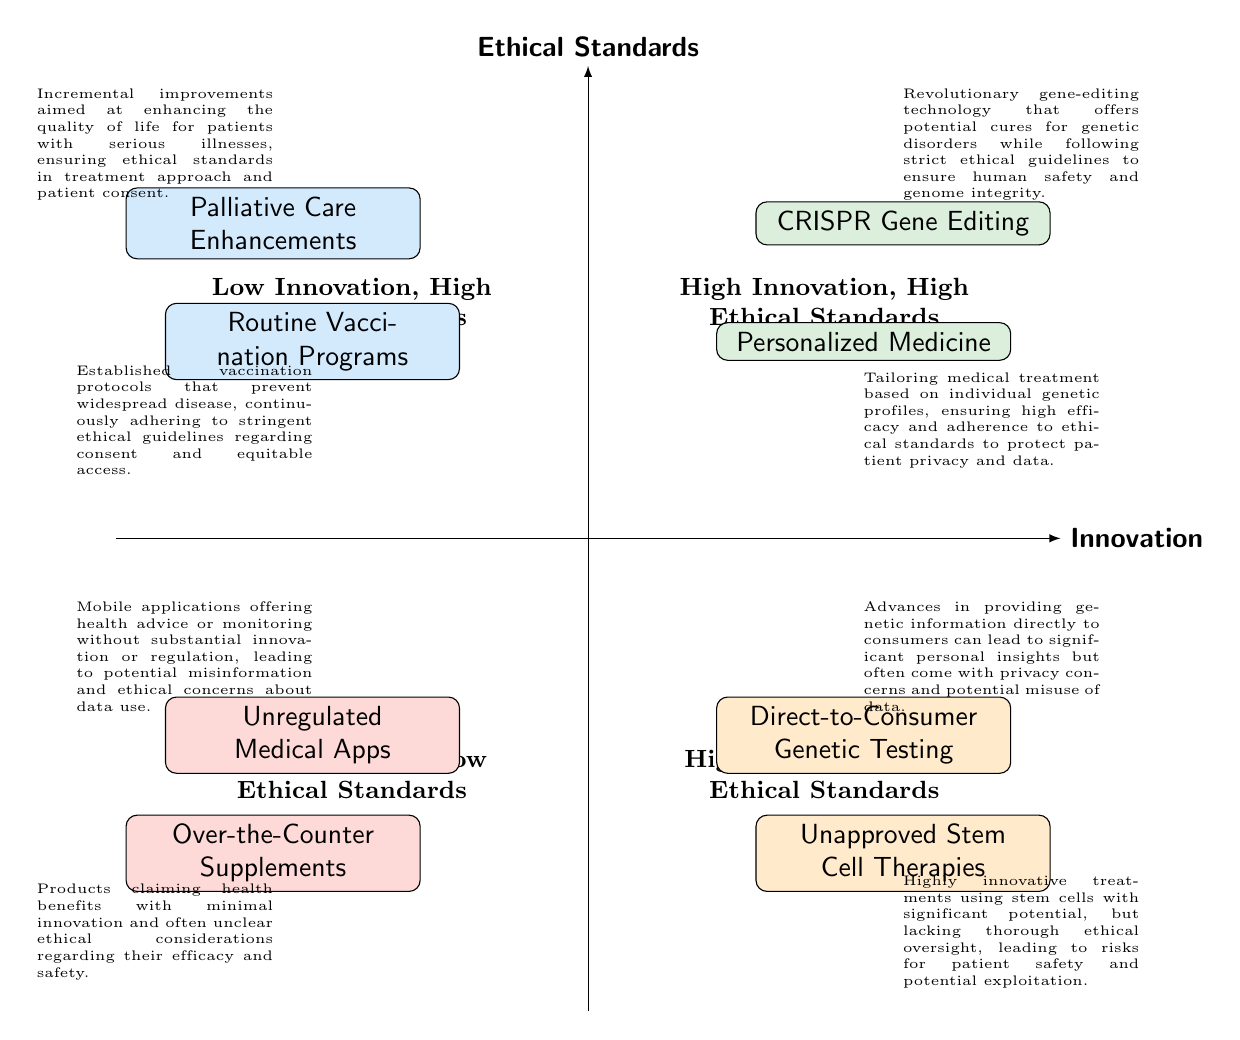What are the two elements in the "High Innovation, High Ethical Standards" quadrant? According to the diagram, the "High Innovation, High Ethical Standards" quadrant contains the elements "CRISPR Gene Editing" and "Personalized Medicine."
Answer: CRISPR Gene Editing, Personalized Medicine How many elements are in the "Low Innovation, Low Ethical Standards" quadrant? The "Low Innovation, Low Ethical Standards" quadrant features two elements: "Over-the-Counter Supplements" and "Unregulated Medical Apps," thus totaling two elements.
Answer: 2 Which quadrant includes "Routine Vaccination Programs"? "Routine Vaccination Programs" is located in the "Low Innovation, High Ethical Standards" quadrant, as indicated in the diagram.
Answer: Low Innovation, High Ethical Standards What is the relationship between "Unapproved Stem Cell Therapies" and ethical standards? "Unapproved Stem Cell Therapies" are categorized under "High Innovation, Low Ethical Standards," which signifies that while they are innovative, they lack sufficient ethical oversight.
Answer: Low Ethical Standards Which quadrant has the least innovation according to the diagram? The quadrant categorized with the least innovation is "Low Innovation, Low Ethical Standards," which contains both "Over-the-Counter Supplements" and "Unregulated Medical Apps."
Answer: Low Innovation, Low Ethical Standards What is a significant ethical concern associated with "Direct-to-Consumer Genetic Testing"? A significant ethical concern with "Direct-to-Consumer Genetic Testing" is privacy, as it involves the potential misuse of personal data and genetic information.
Answer: Privacy concerns Which quadrant features "Palliative Care Enhancements"? "Palliative Care Enhancements" is featured in the "Low Innovation, High Ethical Standards" quadrant, meaning it adheres to high ethical standards despite being an incremental innovation.
Answer: Low Innovation, High Ethical Standards How does "CRISPR Gene Editing" ensure ethical compliance? "CRISPR Gene Editing" maintains ethical compliance by following strict guidelines to ensure human safety and genome integrity in its applications.
Answer: Strict ethical guidelines What distinguishes the "High Innovation, Low Ethical Standards" quadrant from others? The "High Innovation, Low Ethical Standards" quadrant is distinguished by containing innovations that lack sufficient oversight, risking patient safety and ethical implications.
Answer: Lack of sufficient oversight 